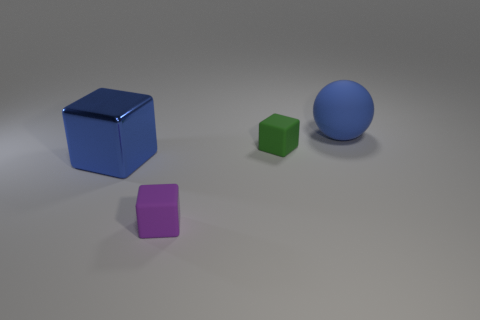Add 2 large blue blocks. How many objects exist? 6 Subtract all tiny rubber cubes. How many cubes are left? 1 Subtract 1 balls. How many balls are left? 0 Subtract all blue cubes. How many cubes are left? 2 Subtract all blocks. How many objects are left? 1 Subtract all green spheres. Subtract all brown cylinders. How many spheres are left? 1 Subtract all big balls. Subtract all rubber spheres. How many objects are left? 2 Add 1 large blue things. How many large blue things are left? 3 Add 3 small things. How many small things exist? 5 Subtract 0 yellow spheres. How many objects are left? 4 